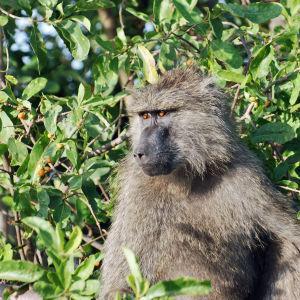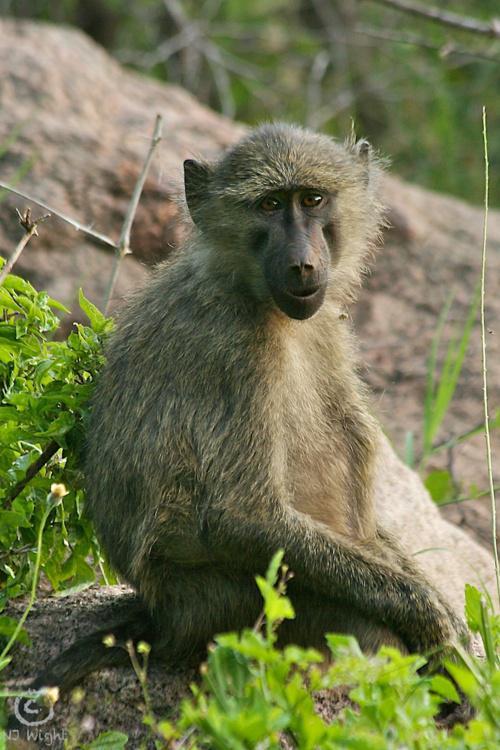The first image is the image on the left, the second image is the image on the right. Given the left and right images, does the statement "Each image contains a single baboon, and no baboon has a wide-open mouth." hold true? Answer yes or no. Yes. The first image is the image on the left, the second image is the image on the right. Given the left and right images, does the statement "There are at least three baboons." hold true? Answer yes or no. No. 